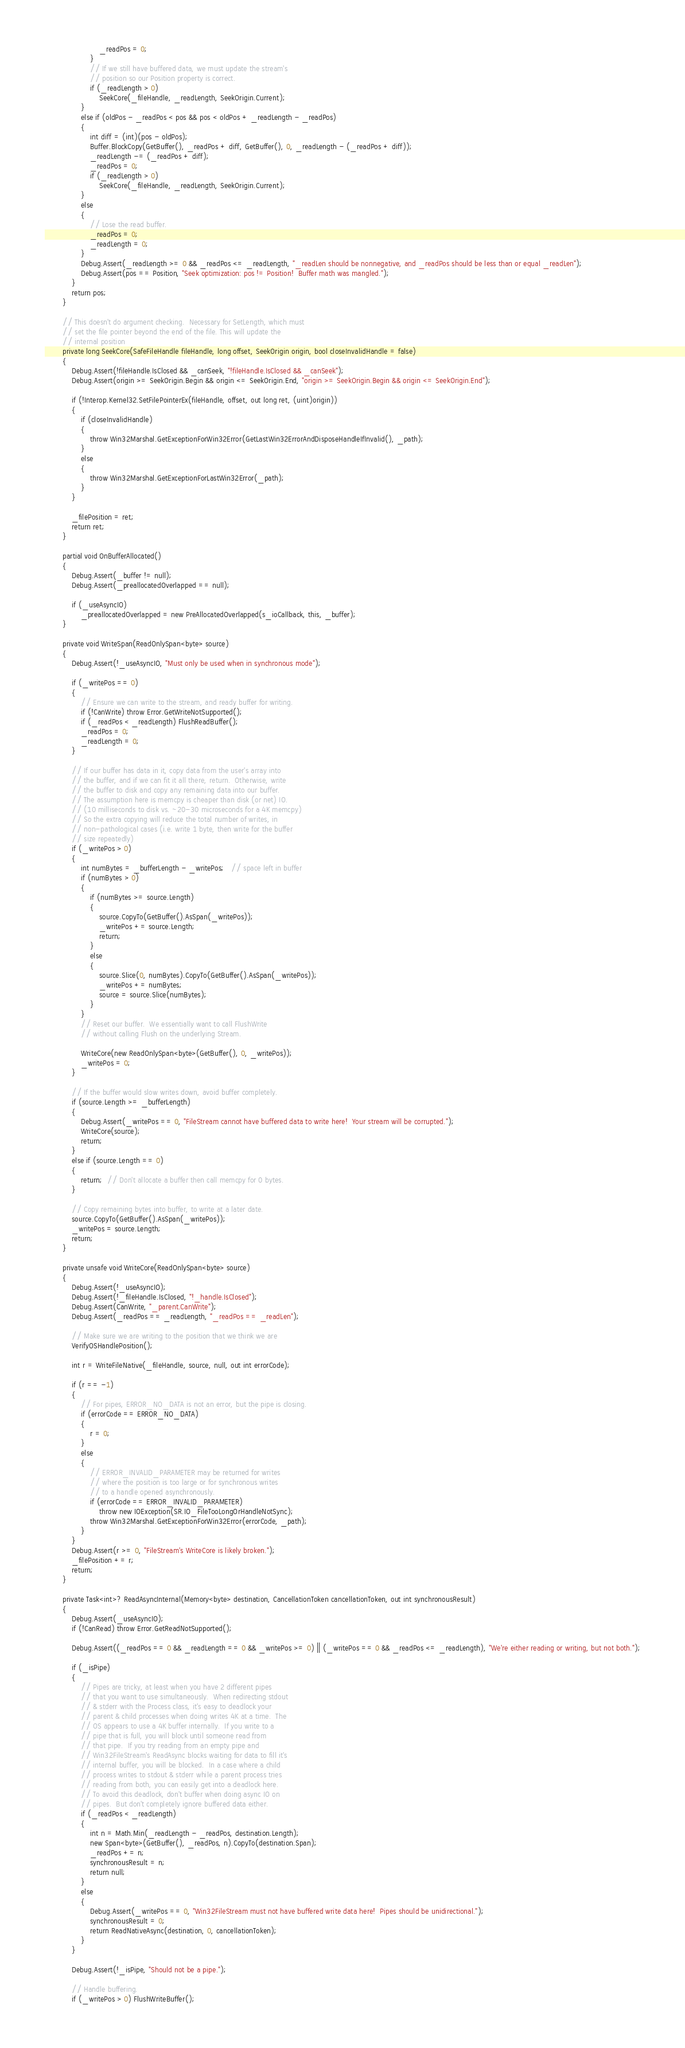<code> <loc_0><loc_0><loc_500><loc_500><_C#_>                        _readPos = 0;
                    }
                    // If we still have buffered data, we must update the stream's
                    // position so our Position property is correct.
                    if (_readLength > 0)
                        SeekCore(_fileHandle, _readLength, SeekOrigin.Current);
                }
                else if (oldPos - _readPos < pos && pos < oldPos + _readLength - _readPos)
                {
                    int diff = (int)(pos - oldPos);
                    Buffer.BlockCopy(GetBuffer(), _readPos + diff, GetBuffer(), 0, _readLength - (_readPos + diff));
                    _readLength -= (_readPos + diff);
                    _readPos = 0;
                    if (_readLength > 0)
                        SeekCore(_fileHandle, _readLength, SeekOrigin.Current);
                }
                else
                {
                    // Lose the read buffer.
                    _readPos = 0;
                    _readLength = 0;
                }
                Debug.Assert(_readLength >= 0 && _readPos <= _readLength, "_readLen should be nonnegative, and _readPos should be less than or equal _readLen");
                Debug.Assert(pos == Position, "Seek optimization: pos != Position!  Buffer math was mangled.");
            }
            return pos;
        }

        // This doesn't do argument checking.  Necessary for SetLength, which must
        // set the file pointer beyond the end of the file. This will update the
        // internal position
        private long SeekCore(SafeFileHandle fileHandle, long offset, SeekOrigin origin, bool closeInvalidHandle = false)
        {
            Debug.Assert(!fileHandle.IsClosed && _canSeek, "!fileHandle.IsClosed && _canSeek");
            Debug.Assert(origin >= SeekOrigin.Begin && origin <= SeekOrigin.End, "origin >= SeekOrigin.Begin && origin <= SeekOrigin.End");

            if (!Interop.Kernel32.SetFilePointerEx(fileHandle, offset, out long ret, (uint)origin))
            {
                if (closeInvalidHandle)
                {
                    throw Win32Marshal.GetExceptionForWin32Error(GetLastWin32ErrorAndDisposeHandleIfInvalid(), _path);
                }
                else
                {
                    throw Win32Marshal.GetExceptionForLastWin32Error(_path);
                }
            }

            _filePosition = ret;
            return ret;
        }

        partial void OnBufferAllocated()
        {
            Debug.Assert(_buffer != null);
            Debug.Assert(_preallocatedOverlapped == null);

            if (_useAsyncIO)
                _preallocatedOverlapped = new PreAllocatedOverlapped(s_ioCallback, this, _buffer);
        }

        private void WriteSpan(ReadOnlySpan<byte> source)
        {
            Debug.Assert(!_useAsyncIO, "Must only be used when in synchronous mode");

            if (_writePos == 0)
            {
                // Ensure we can write to the stream, and ready buffer for writing.
                if (!CanWrite) throw Error.GetWriteNotSupported();
                if (_readPos < _readLength) FlushReadBuffer();
                _readPos = 0;
                _readLength = 0;
            }

            // If our buffer has data in it, copy data from the user's array into
            // the buffer, and if we can fit it all there, return.  Otherwise, write
            // the buffer to disk and copy any remaining data into our buffer.
            // The assumption here is memcpy is cheaper than disk (or net) IO.
            // (10 milliseconds to disk vs. ~20-30 microseconds for a 4K memcpy)
            // So the extra copying will reduce the total number of writes, in
            // non-pathological cases (i.e. write 1 byte, then write for the buffer
            // size repeatedly)
            if (_writePos > 0)
            {
                int numBytes = _bufferLength - _writePos;   // space left in buffer
                if (numBytes > 0)
                {
                    if (numBytes >= source.Length)
                    {
                        source.CopyTo(GetBuffer().AsSpan(_writePos));
                        _writePos += source.Length;
                        return;
                    }
                    else
                    {
                        source.Slice(0, numBytes).CopyTo(GetBuffer().AsSpan(_writePos));
                        _writePos += numBytes;
                        source = source.Slice(numBytes);
                    }
                }
                // Reset our buffer.  We essentially want to call FlushWrite
                // without calling Flush on the underlying Stream.

                WriteCore(new ReadOnlySpan<byte>(GetBuffer(), 0, _writePos));
                _writePos = 0;
            }

            // If the buffer would slow writes down, avoid buffer completely.
            if (source.Length >= _bufferLength)
            {
                Debug.Assert(_writePos == 0, "FileStream cannot have buffered data to write here!  Your stream will be corrupted.");
                WriteCore(source);
                return;
            }
            else if (source.Length == 0)
            {
                return;  // Don't allocate a buffer then call memcpy for 0 bytes.
            }

            // Copy remaining bytes into buffer, to write at a later date.
            source.CopyTo(GetBuffer().AsSpan(_writePos));
            _writePos = source.Length;
            return;
        }

        private unsafe void WriteCore(ReadOnlySpan<byte> source)
        {
            Debug.Assert(!_useAsyncIO);
            Debug.Assert(!_fileHandle.IsClosed, "!_handle.IsClosed");
            Debug.Assert(CanWrite, "_parent.CanWrite");
            Debug.Assert(_readPos == _readLength, "_readPos == _readLen");

            // Make sure we are writing to the position that we think we are
            VerifyOSHandlePosition();

            int r = WriteFileNative(_fileHandle, source, null, out int errorCode);

            if (r == -1)
            {
                // For pipes, ERROR_NO_DATA is not an error, but the pipe is closing.
                if (errorCode == ERROR_NO_DATA)
                {
                    r = 0;
                }
                else
                {
                    // ERROR_INVALID_PARAMETER may be returned for writes
                    // where the position is too large or for synchronous writes
                    // to a handle opened asynchronously.
                    if (errorCode == ERROR_INVALID_PARAMETER)
                        throw new IOException(SR.IO_FileTooLongOrHandleNotSync);
                    throw Win32Marshal.GetExceptionForWin32Error(errorCode, _path);
                }
            }
            Debug.Assert(r >= 0, "FileStream's WriteCore is likely broken.");
            _filePosition += r;
            return;
        }

        private Task<int>? ReadAsyncInternal(Memory<byte> destination, CancellationToken cancellationToken, out int synchronousResult)
        {
            Debug.Assert(_useAsyncIO);
            if (!CanRead) throw Error.GetReadNotSupported();

            Debug.Assert((_readPos == 0 && _readLength == 0 && _writePos >= 0) || (_writePos == 0 && _readPos <= _readLength), "We're either reading or writing, but not both.");

            if (_isPipe)
            {
                // Pipes are tricky, at least when you have 2 different pipes
                // that you want to use simultaneously.  When redirecting stdout
                // & stderr with the Process class, it's easy to deadlock your
                // parent & child processes when doing writes 4K at a time.  The
                // OS appears to use a 4K buffer internally.  If you write to a
                // pipe that is full, you will block until someone read from
                // that pipe.  If you try reading from an empty pipe and
                // Win32FileStream's ReadAsync blocks waiting for data to fill it's
                // internal buffer, you will be blocked.  In a case where a child
                // process writes to stdout & stderr while a parent process tries
                // reading from both, you can easily get into a deadlock here.
                // To avoid this deadlock, don't buffer when doing async IO on
                // pipes.  But don't completely ignore buffered data either.
                if (_readPos < _readLength)
                {
                    int n = Math.Min(_readLength - _readPos, destination.Length);
                    new Span<byte>(GetBuffer(), _readPos, n).CopyTo(destination.Span);
                    _readPos += n;
                    synchronousResult = n;
                    return null;
                }
                else
                {
                    Debug.Assert(_writePos == 0, "Win32FileStream must not have buffered write data here!  Pipes should be unidirectional.");
                    synchronousResult = 0;
                    return ReadNativeAsync(destination, 0, cancellationToken);
                }
            }

            Debug.Assert(!_isPipe, "Should not be a pipe.");

            // Handle buffering.
            if (_writePos > 0) FlushWriteBuffer();</code> 